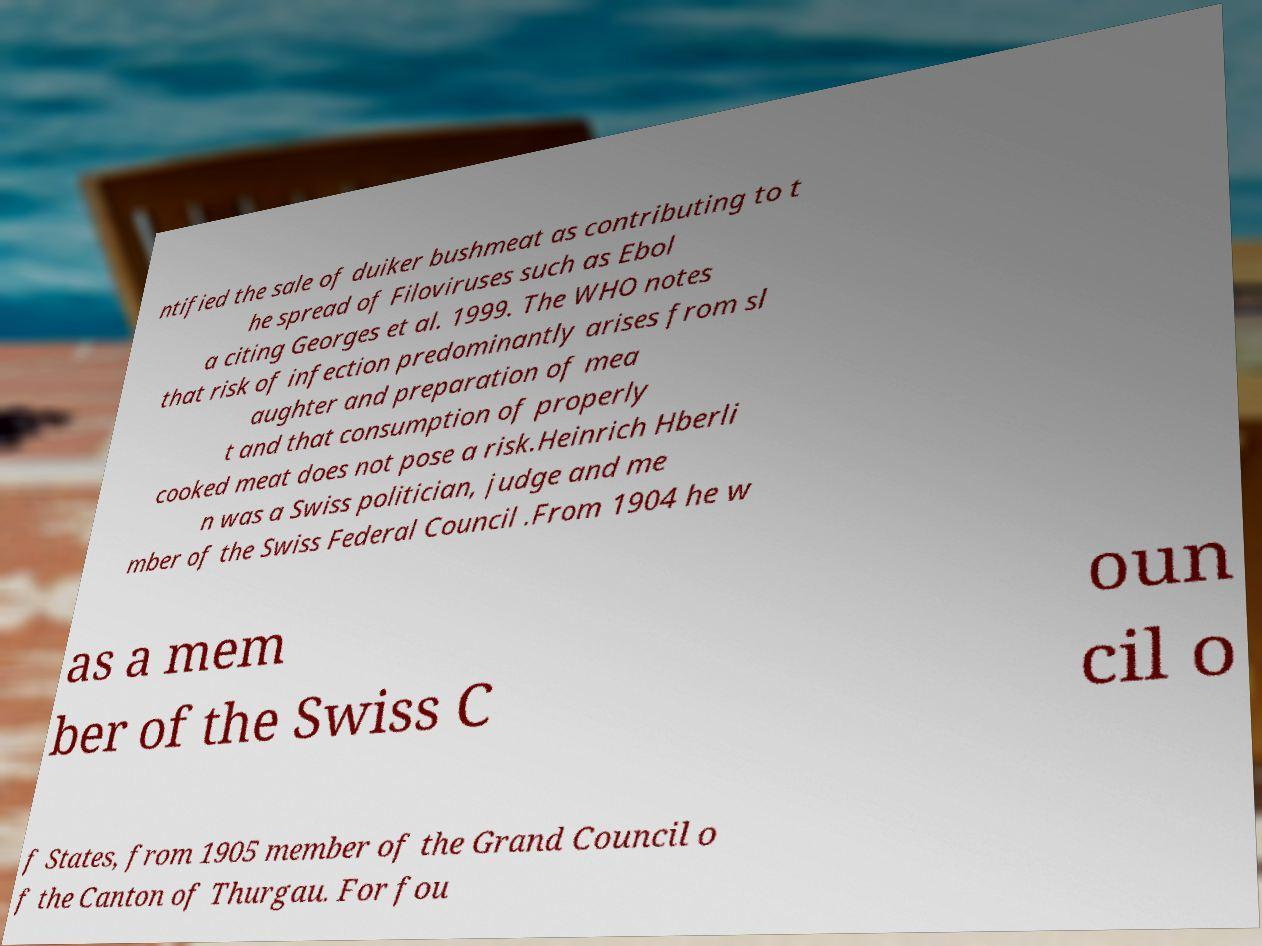Could you assist in decoding the text presented in this image and type it out clearly? ntified the sale of duiker bushmeat as contributing to t he spread of Filoviruses such as Ebol a citing Georges et al. 1999. The WHO notes that risk of infection predominantly arises from sl aughter and preparation of mea t and that consumption of properly cooked meat does not pose a risk.Heinrich Hberli n was a Swiss politician, judge and me mber of the Swiss Federal Council .From 1904 he w as a mem ber of the Swiss C oun cil o f States, from 1905 member of the Grand Council o f the Canton of Thurgau. For fou 